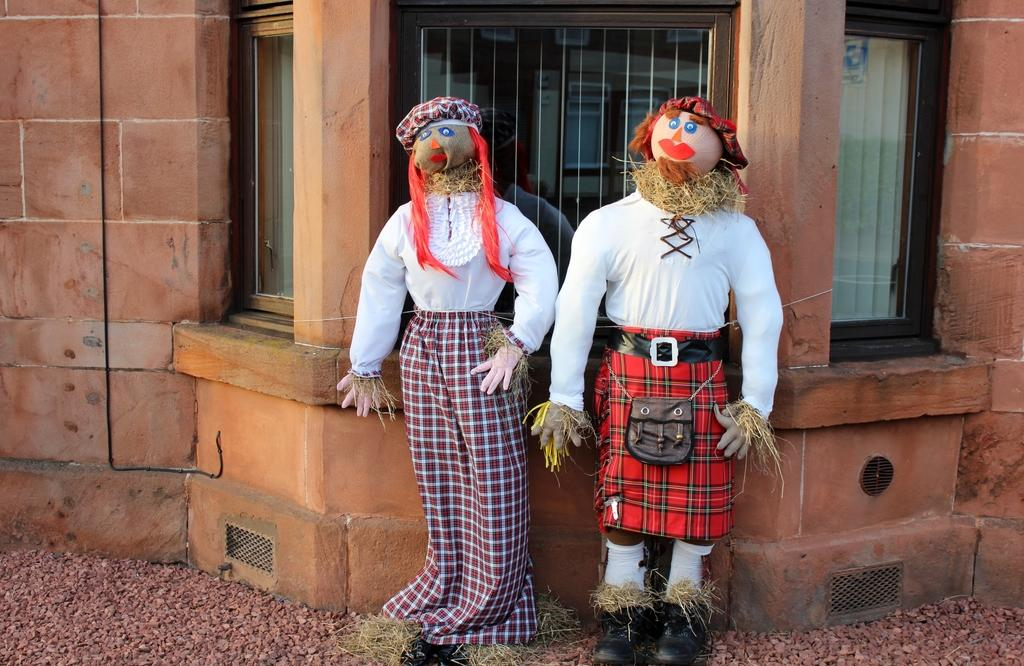What can be seen in the foreground of the image? There are two scarecrows in the foreground of the image. What architectural features are visible in the image? There are windows and a wall visible in the image. What type of whip can be seen in the scarecrow's hand in the image? There is no whip present in the image; the scarecrows do not have any objects in their hands. 